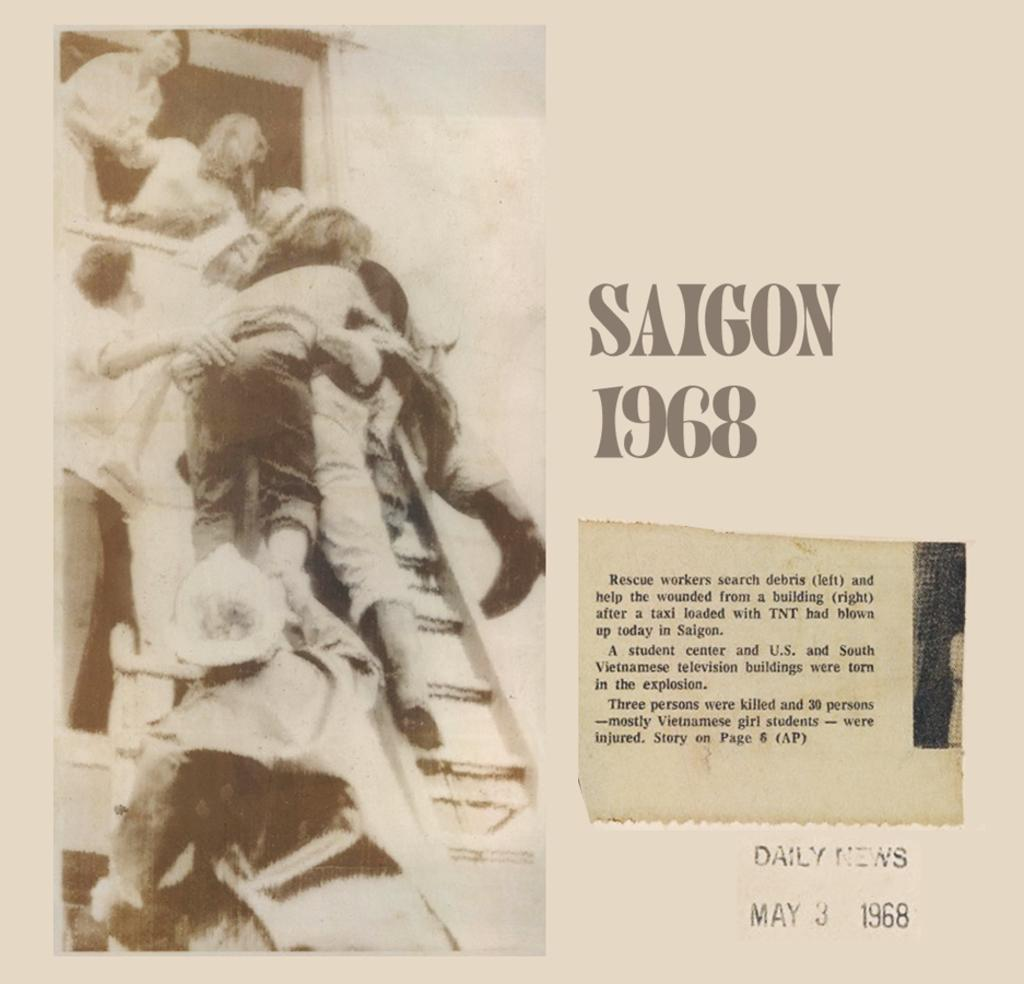What can be seen in the image? There is a poster in the image. What is written or printed on the poster? There is text printed on the poster. How many clocks are displayed on the poster in the image? There is no mention of clocks in the image, as the facts only mention a poster with text. 